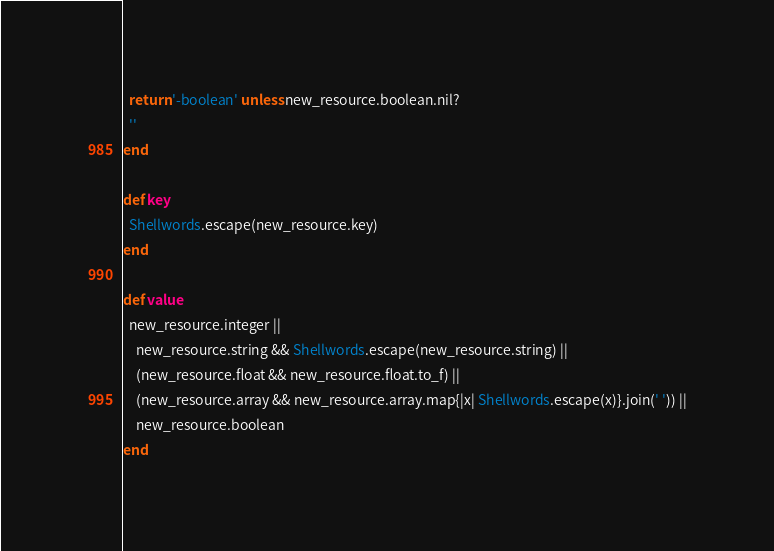Convert code to text. <code><loc_0><loc_0><loc_500><loc_500><_Ruby_>  return '-boolean' unless new_resource.boolean.nil?
  ''
end

def key
  Shellwords.escape(new_resource.key)
end

def value
  new_resource.integer ||
    new_resource.string && Shellwords.escape(new_resource.string) ||
    (new_resource.float && new_resource.float.to_f) ||
    (new_resource.array && new_resource.array.map{|x| Shellwords.escape(x)}.join(' ')) ||
    new_resource.boolean
end
</code> 